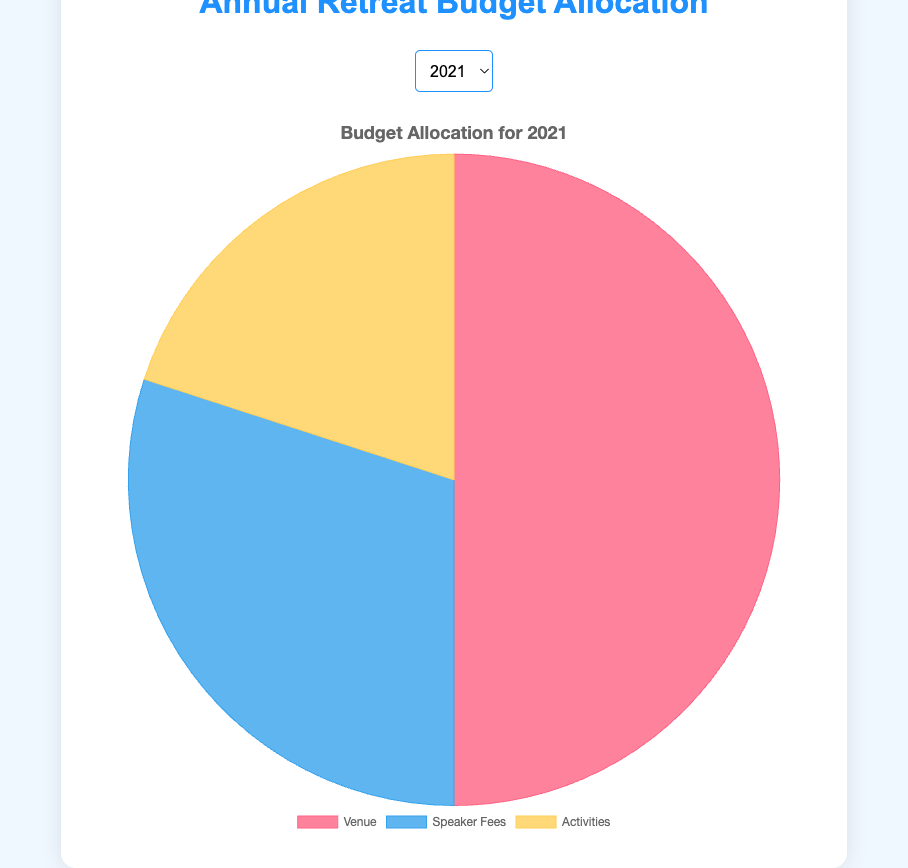What is the budget allocated to Venue in 2021? The pie chart for 2021 shows the portions of the budget for Venue, Speaker Fees, and Activities. Locate the segment labeled "Venue" and read the value associated with it.
Answer: $25,000 How does the Speaker Fees budget in 2024 compare to that in 2021? Identify the pie segments labeled "Speaker Fees" for both years 2021 and 2024, and then compare the values. 2024 Speaker Fees are $22,000, and 2021 Speaker Fees are $15,000. So $22,000 - $15,000 = $7,000 more.
Answer: $7,000 more Which component (Venue, Speaker Fees, Activities) saw the most significant increase from 2021 to 2024? Calculate the difference in the budget for each component from 2021 to 2024. Venue increased by ($32,000 - $25,000 = $7,000), Speaker Fees increased by ($22,000 - $15,000 = $7,000), and Activities increased by ($15,000 - $10,000 = $5,000). Both Venue and Speaker Fees saw the highest increase of $7,000 each.
Answer: Venue and Speaker Fees What is the total budget for Activities over the years 2021, 2022, 2023, and 2024? Add the Activities budget for each year: $10,000 (2021) + $12,000 (2022) + $13,000 (2023) + $15,000 (2024).
Answer: $50,000 What percentage of the total budget for 2023 is allocated to Speaker Fees? Sum the total budget for 2023: Venue ($30,000) + Speaker Fees ($20,000) + Activities ($13,000) = $63,000. Then calculate the percentage for Speaker Fees: ($20,000 / $63,000) * 100%.
Answer: 31.7% Which year has the highest total budget? Calculate the total budget for each year and compare them. 2021: $25,000 + $15,000 + $10,000 = $50,000, 2022: $28,000 + $17,000 + $12,000 = $57,000, 2023: $30,000 + $20,000 + $13,000 = $63,000, 2024: $32,000 + $22,000 + $15,000 = $69,000. The highest total budget is in 2024.
Answer: 2024 